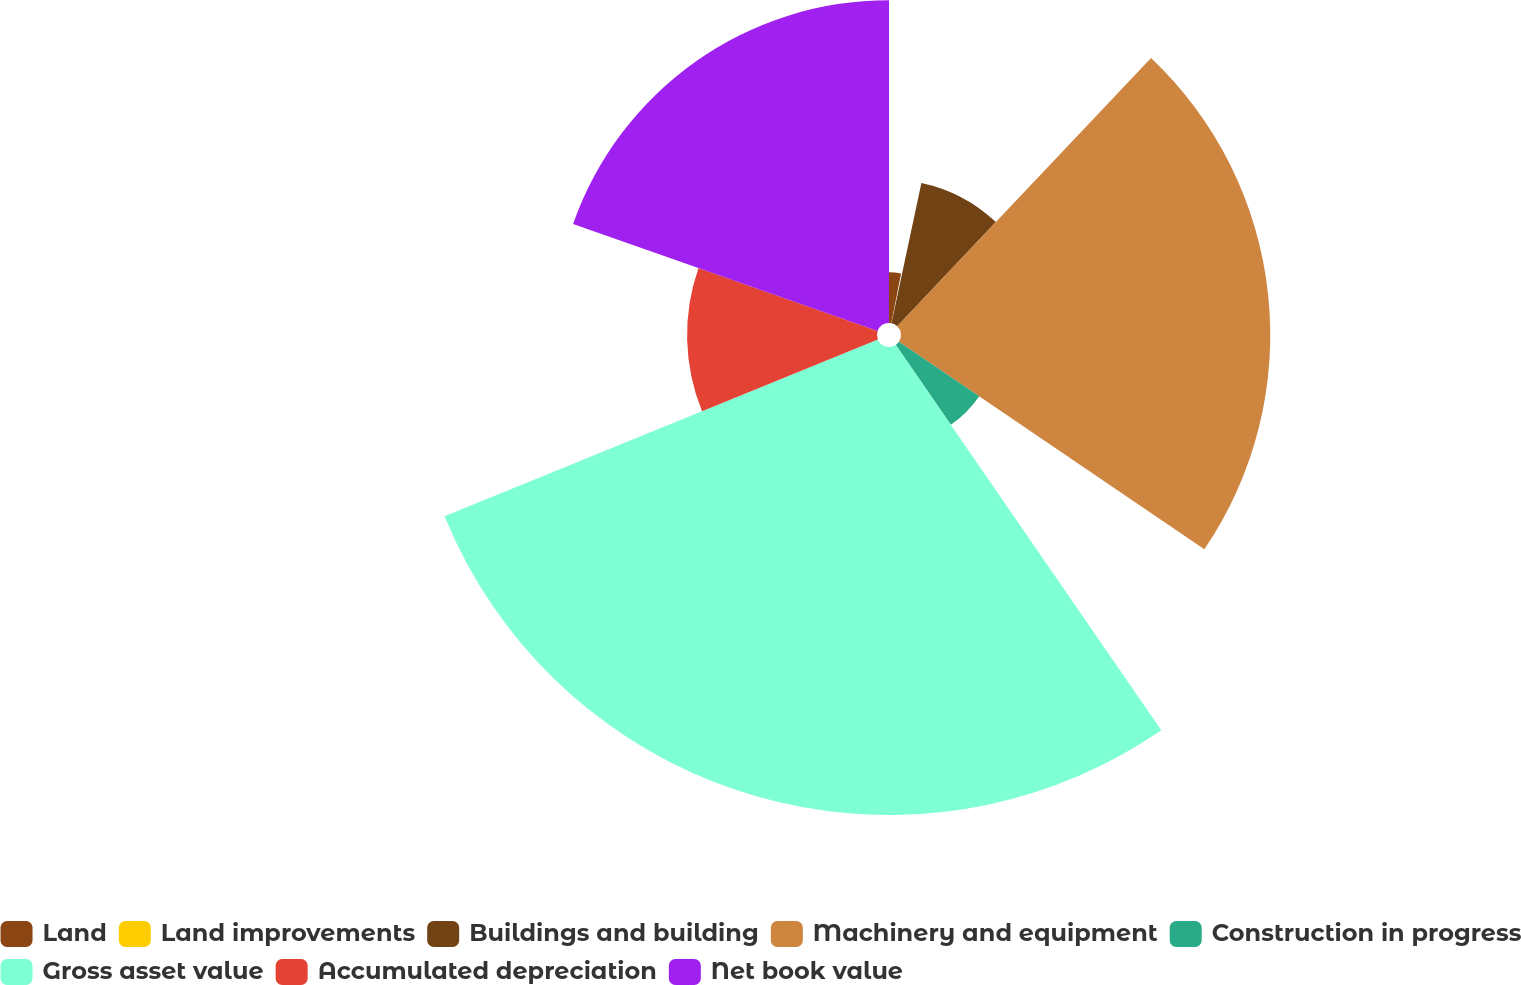Convert chart. <chart><loc_0><loc_0><loc_500><loc_500><pie_chart><fcel>Land<fcel>Land improvements<fcel>Buildings and building<fcel>Machinery and equipment<fcel>Construction in progress<fcel>Gross asset value<fcel>Accumulated depreciation<fcel>Net book value<nl><fcel>3.08%<fcel>0.26%<fcel>8.72%<fcel>22.44%<fcel>5.9%<fcel>28.44%<fcel>11.54%<fcel>19.62%<nl></chart> 